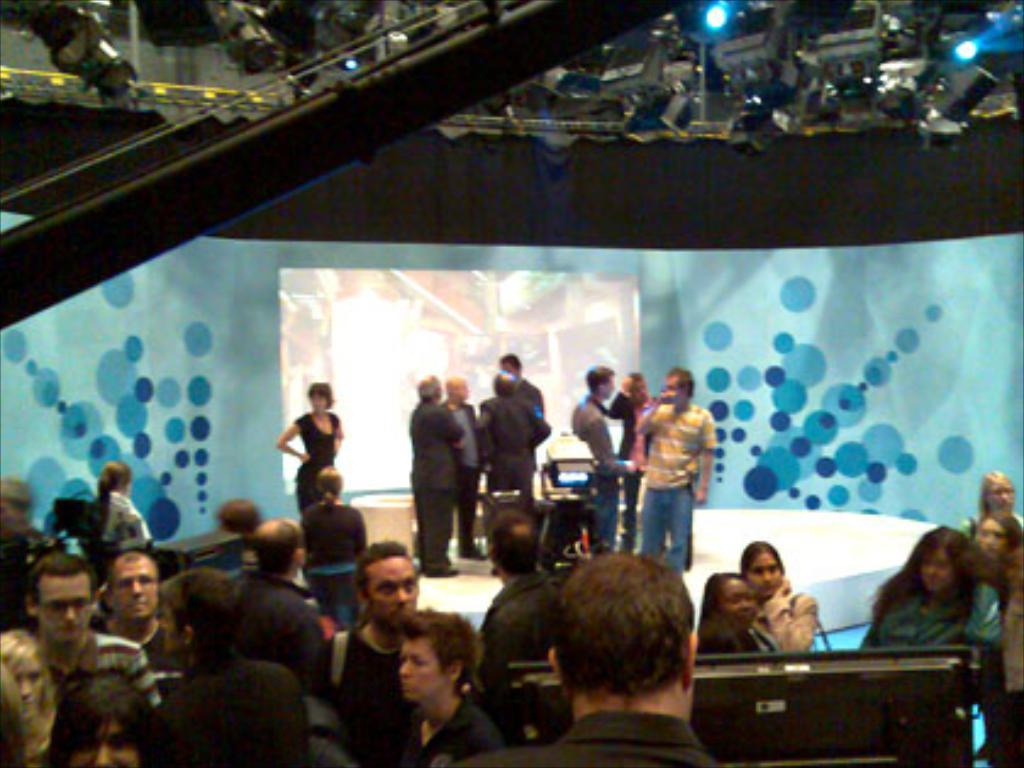What is happening on the stage in the image? There are people on the stage in the image. Where are the other people located in the image? There are people on the floor in the image. What is present at the top of the image? There are cameras and lights at the top of the image. What can be used to display information or visuals in the image? A screen is visible in the image. What type of paste is being used by the people on the stage in the image? There is no mention of paste in the image, and it is not visible in the provided facts. What hobbies do the people on the floor in the image enjoy? The provided facts do not give any information about the hobbies of the people in the image. 